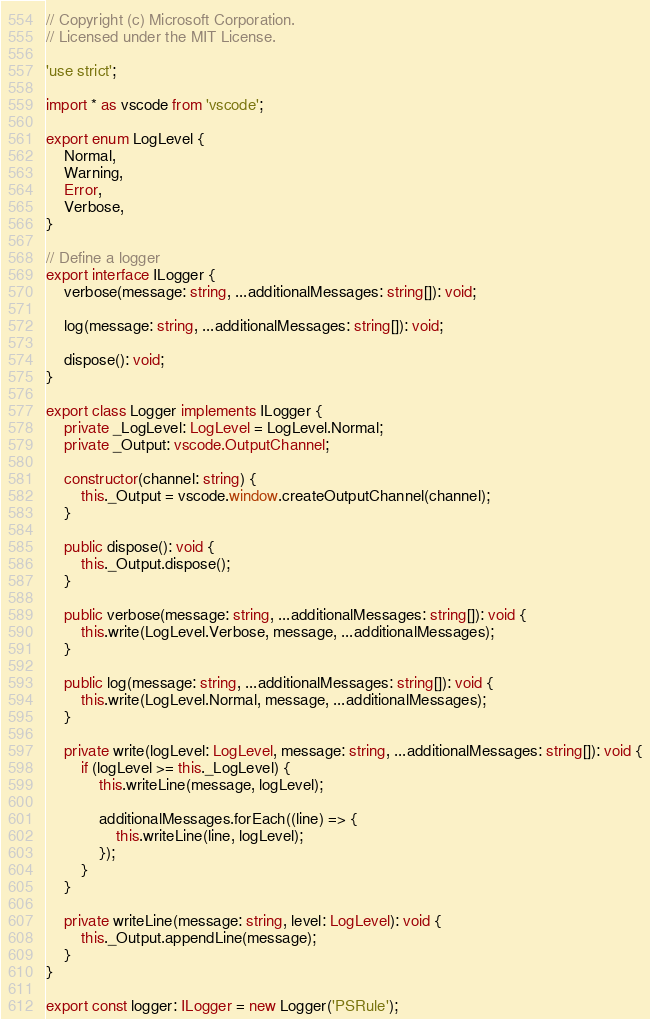Convert code to text. <code><loc_0><loc_0><loc_500><loc_500><_TypeScript_>// Copyright (c) Microsoft Corporation.
// Licensed under the MIT License.

'use strict';

import * as vscode from 'vscode';

export enum LogLevel {
    Normal,
    Warning,
    Error,
    Verbose,
}

// Define a logger
export interface ILogger {
    verbose(message: string, ...additionalMessages: string[]): void;

    log(message: string, ...additionalMessages: string[]): void;

    dispose(): void;
}

export class Logger implements ILogger {
    private _LogLevel: LogLevel = LogLevel.Normal;
    private _Output: vscode.OutputChannel;

    constructor(channel: string) {
        this._Output = vscode.window.createOutputChannel(channel);
    }

    public dispose(): void {
        this._Output.dispose();
    }

    public verbose(message: string, ...additionalMessages: string[]): void {
        this.write(LogLevel.Verbose, message, ...additionalMessages);
    }

    public log(message: string, ...additionalMessages: string[]): void {
        this.write(LogLevel.Normal, message, ...additionalMessages);
    }

    private write(logLevel: LogLevel, message: string, ...additionalMessages: string[]): void {
        if (logLevel >= this._LogLevel) {
            this.writeLine(message, logLevel);

            additionalMessages.forEach((line) => {
                this.writeLine(line, logLevel);
            });
        }
    }

    private writeLine(message: string, level: LogLevel): void {
        this._Output.appendLine(message);
    }
}

export const logger: ILogger = new Logger('PSRule');
</code> 